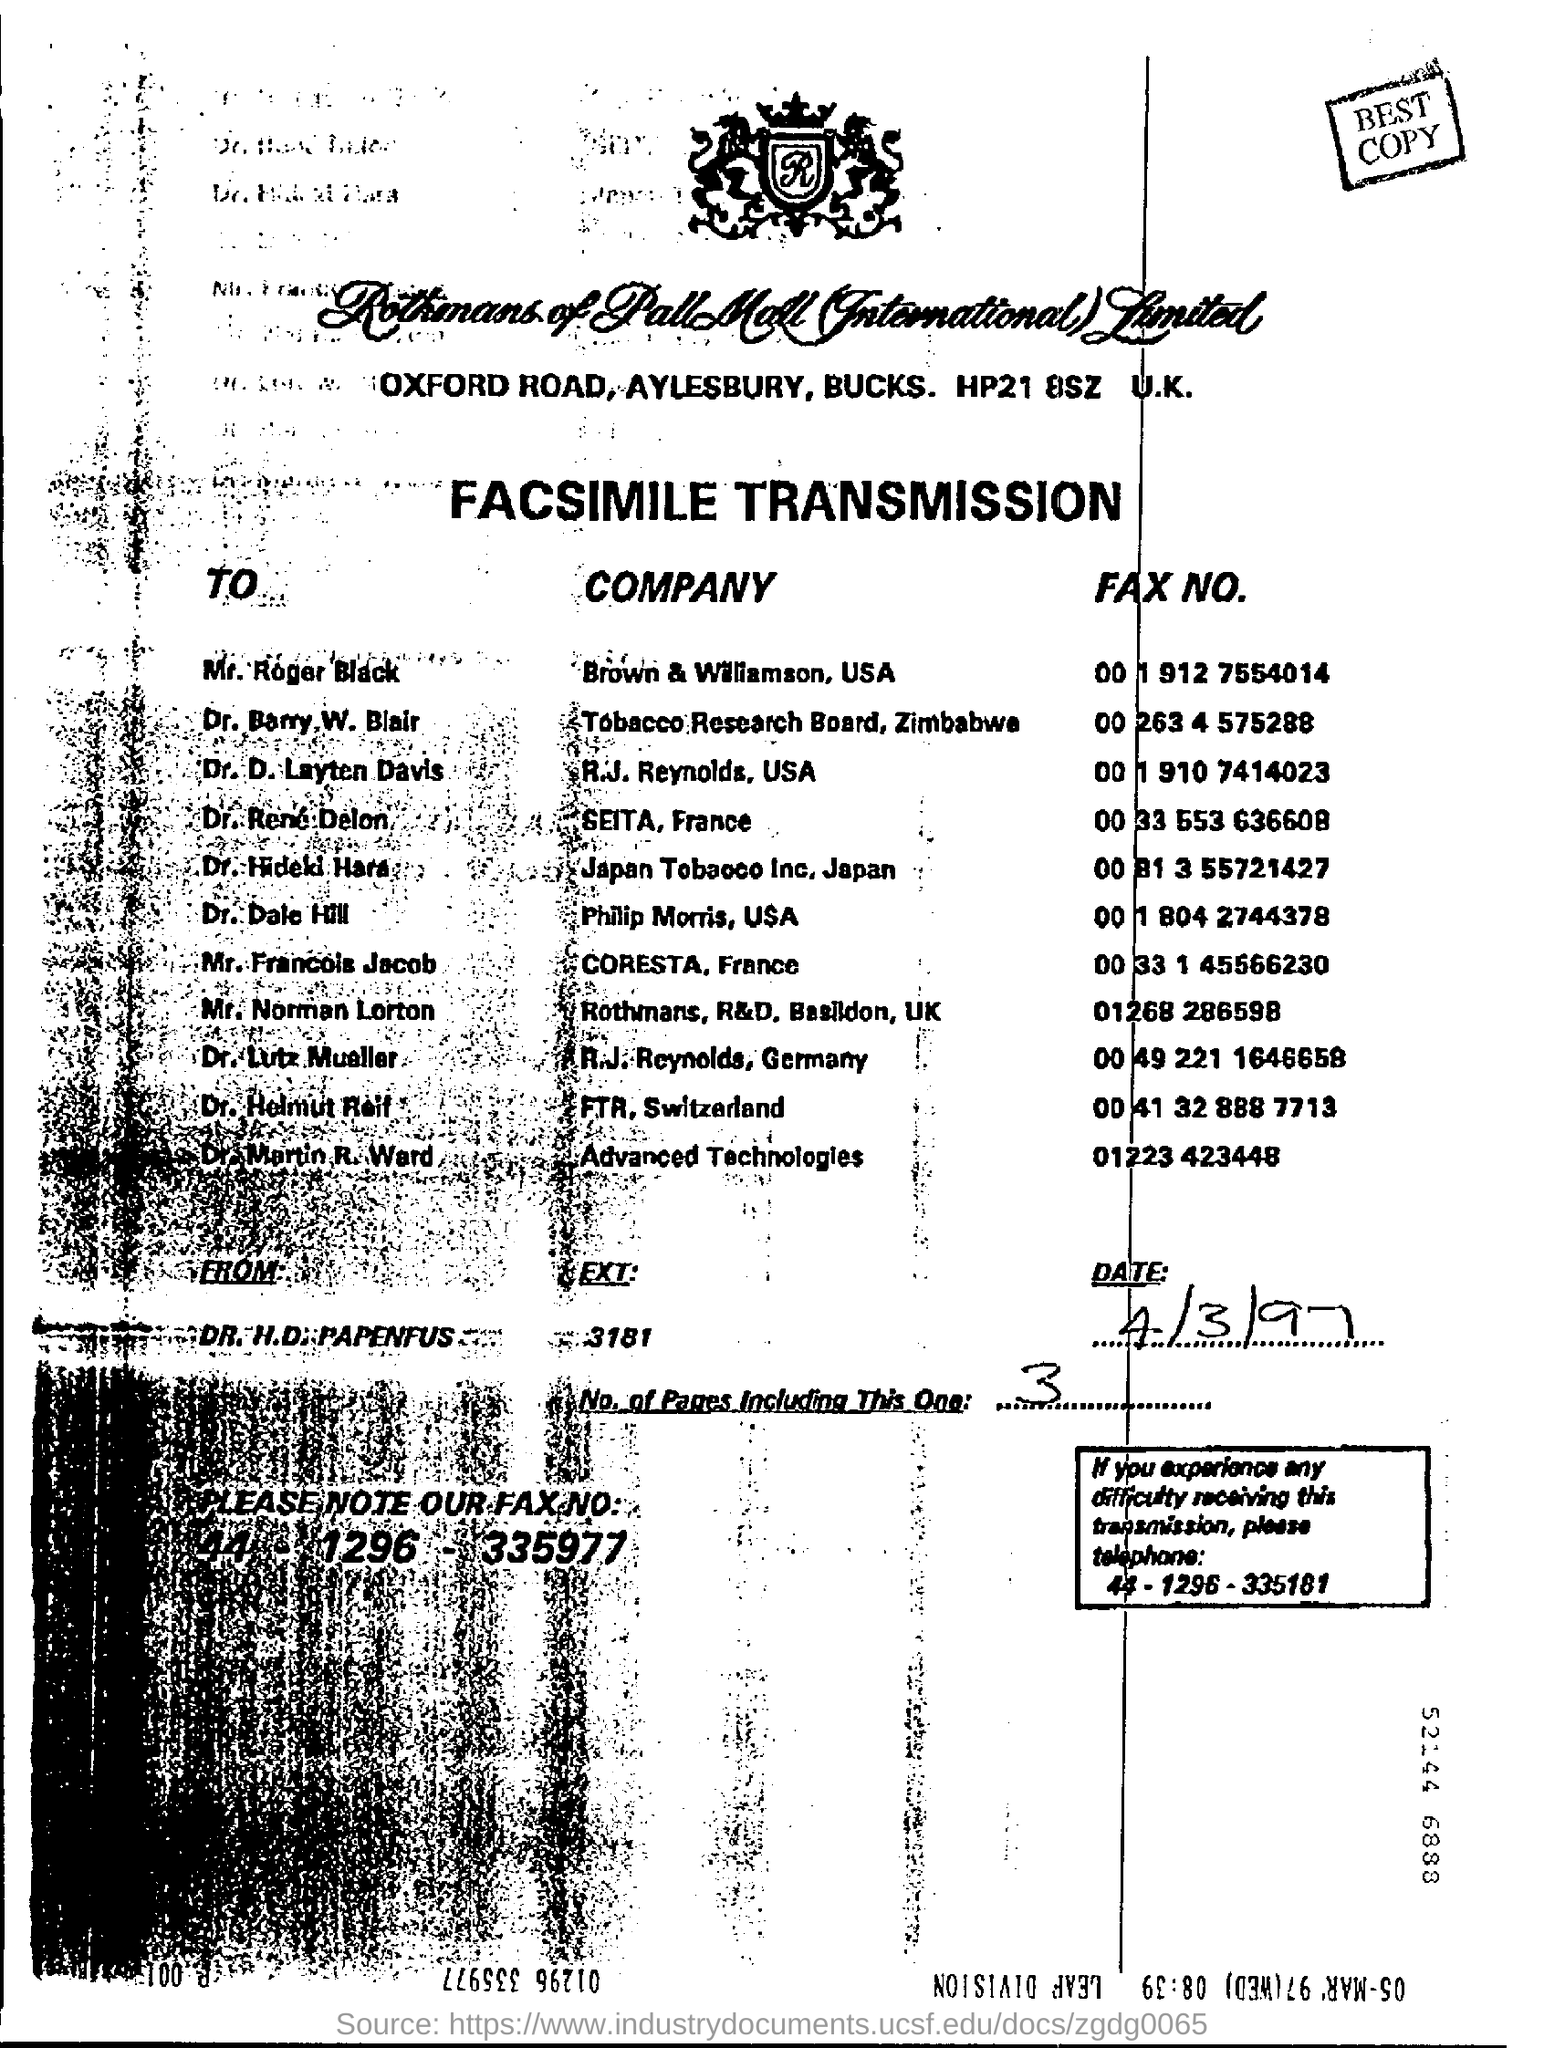What are written on top of page in rectangle box
Give a very brief answer. Best copy. Which letter is written on top of the page in design
Ensure brevity in your answer.  R. 